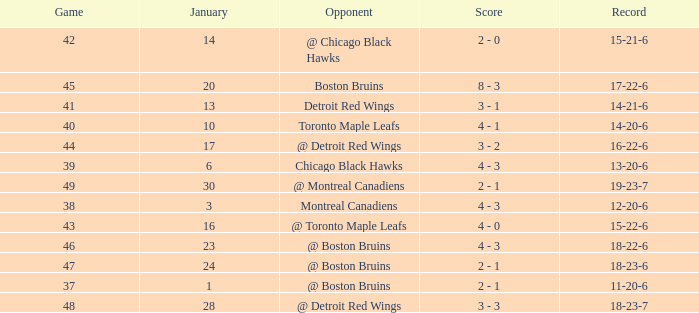Who was the opponent with the record of 15-21-6? @ Chicago Black Hawks. 